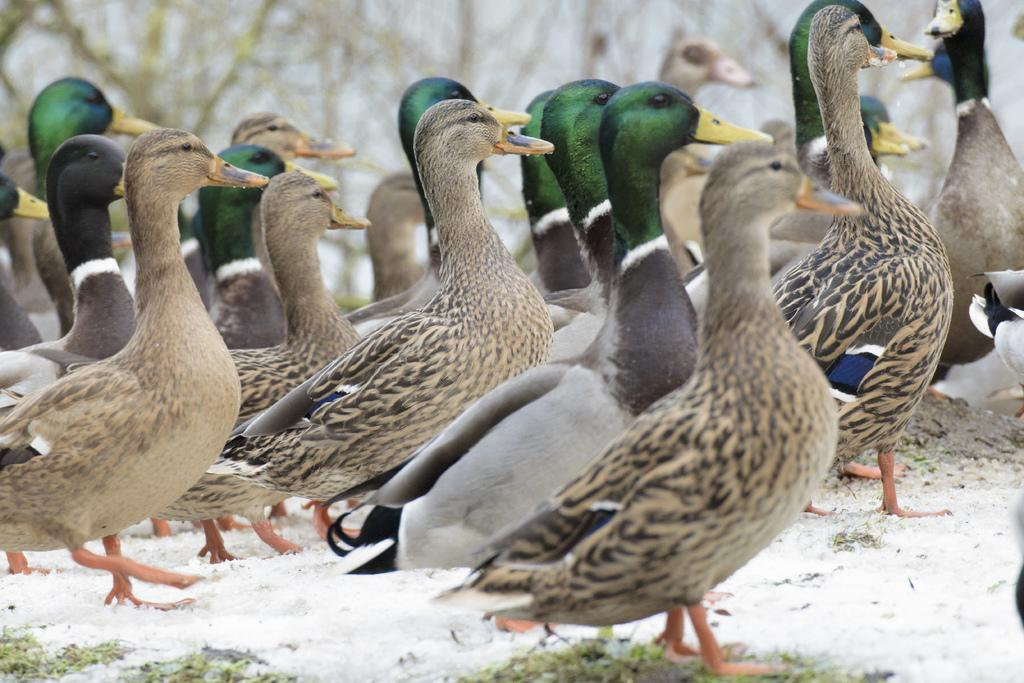What type of animals can be seen in the image? There are birds in the image. Can you describe the background of the image? The background of the image is blurred. What type of mouth does the bird have in the image? There is no specific detail about the bird's mouth in the image, as it is not focused on in the provided facts. 